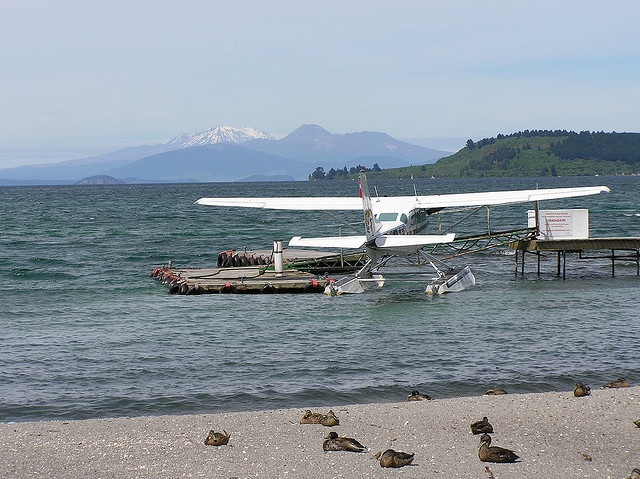Describe the objects in this image and their specific colors. I can see airplane in lavender, white, gray, darkgray, and black tones, bird in lavender, darkgray, gray, black, and tan tones, bird in lavender, black, and gray tones, bird in lavender, black, and gray tones, and bird in lavender, black, gray, and maroon tones in this image. 